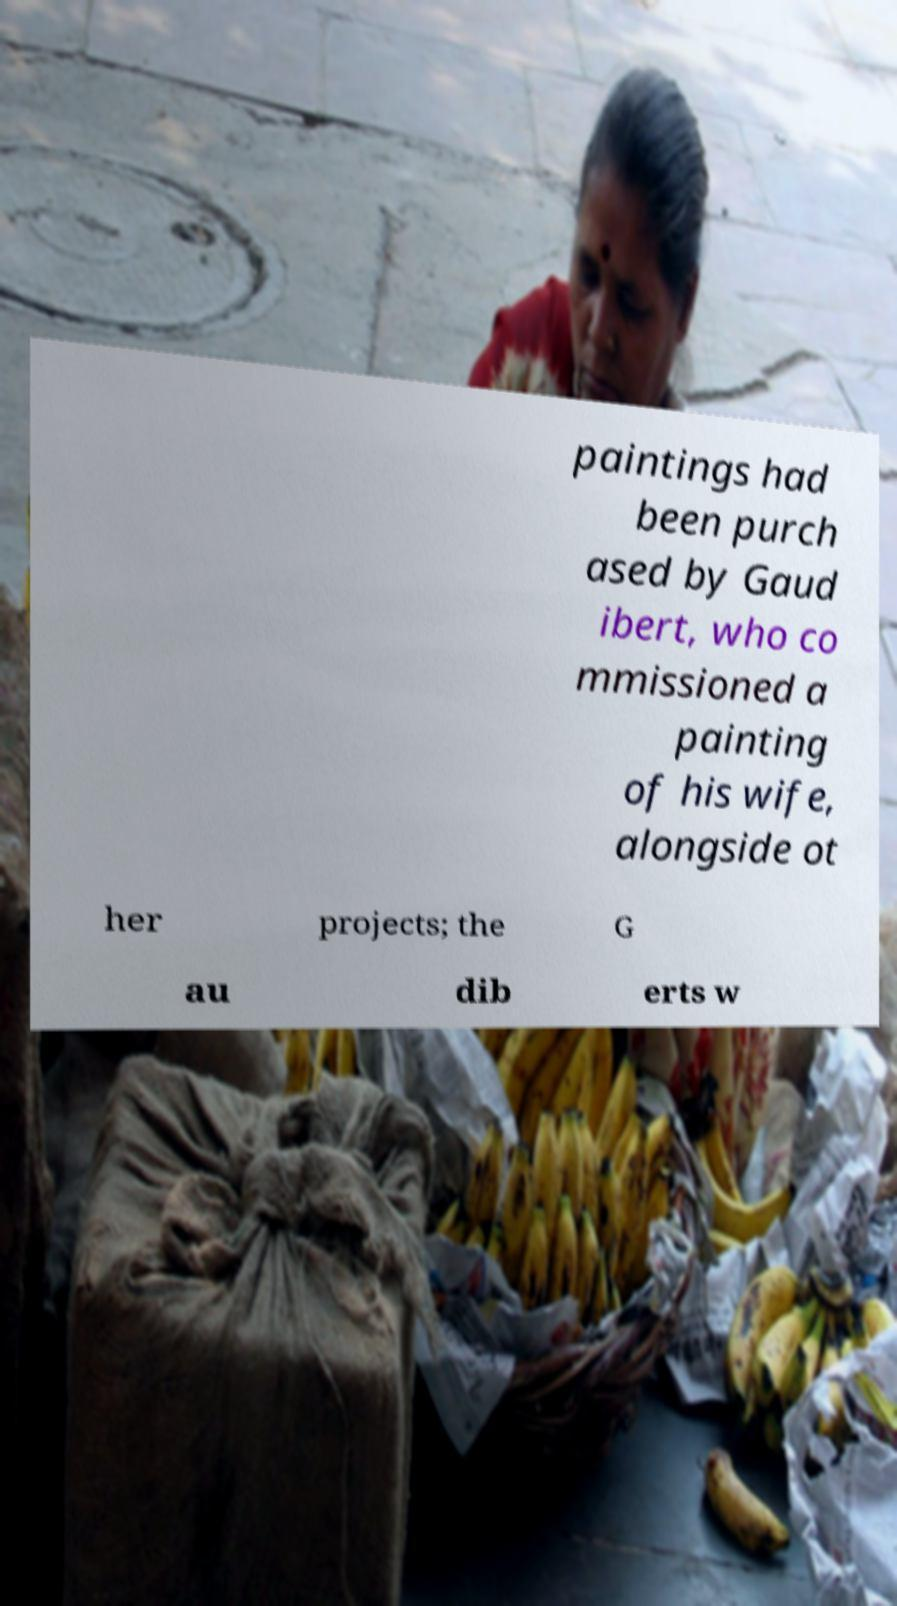I need the written content from this picture converted into text. Can you do that? paintings had been purch ased by Gaud ibert, who co mmissioned a painting of his wife, alongside ot her projects; the G au dib erts w 